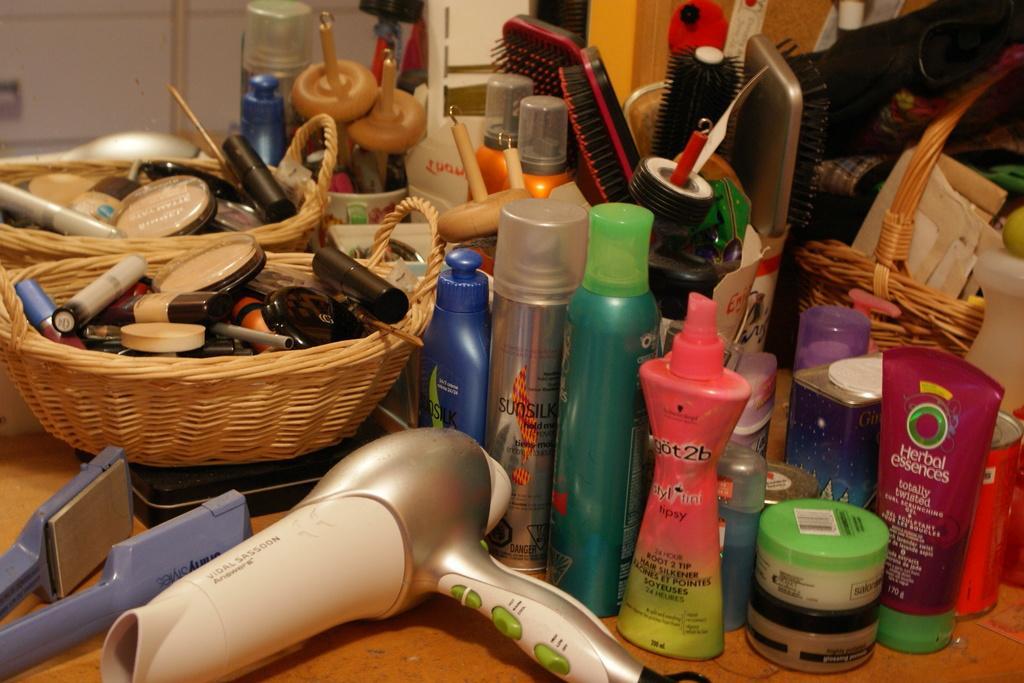<image>
Relay a brief, clear account of the picture shown. A messy bathroom counter has a hairdryer and hair products including a pink bottle of got2b spray. 